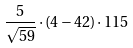<formula> <loc_0><loc_0><loc_500><loc_500>\frac { 5 } { \sqrt { 5 9 } } \cdot ( 4 - 4 2 ) \cdot 1 1 5</formula> 